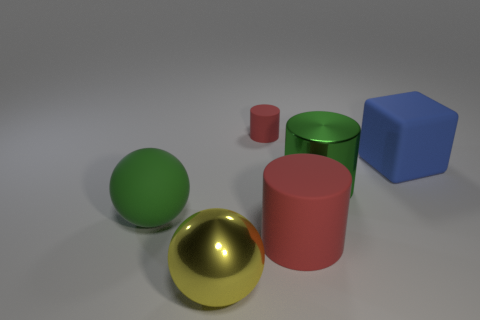There is another thing that is the same shape as the large yellow object; what is it made of?
Provide a succinct answer. Rubber. There is a matte object that is on the left side of the large yellow thing; is its color the same as the shiny thing that is behind the big metal ball?
Your answer should be compact. Yes. Is there a sphere that has the same size as the blue matte block?
Offer a very short reply. Yes. What is the material of the object that is both to the left of the big shiny cylinder and behind the green rubber ball?
Offer a very short reply. Rubber. What number of metal things are tiny green cubes or large red cylinders?
Give a very brief answer. 0. There is a tiny red object that is made of the same material as the large red cylinder; what shape is it?
Make the answer very short. Cylinder. How many big matte things are on the left side of the tiny red cylinder and right of the small red rubber thing?
Keep it short and to the point. 0. Is there any other thing that has the same shape as the yellow shiny object?
Offer a terse response. Yes. There is a green metallic thing that is behind the big green ball; how big is it?
Your answer should be very brief. Large. How many other things are there of the same color as the large rubber ball?
Offer a very short reply. 1. 